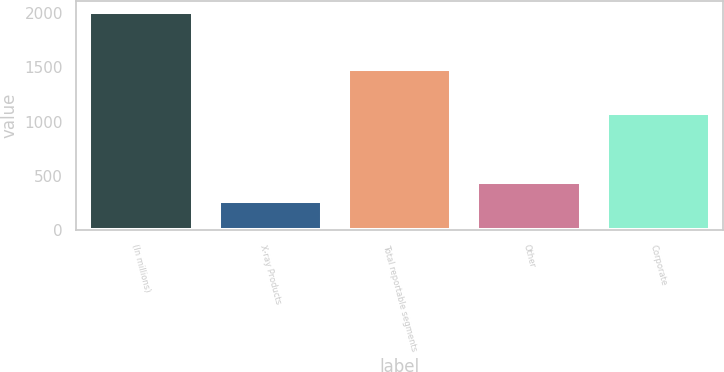Convert chart to OTSL. <chart><loc_0><loc_0><loc_500><loc_500><bar_chart><fcel>(In millions)<fcel>X-ray Products<fcel>Total reportable segments<fcel>Other<fcel>Corporate<nl><fcel>2012<fcel>265<fcel>1485<fcel>439.7<fcel>1081<nl></chart> 